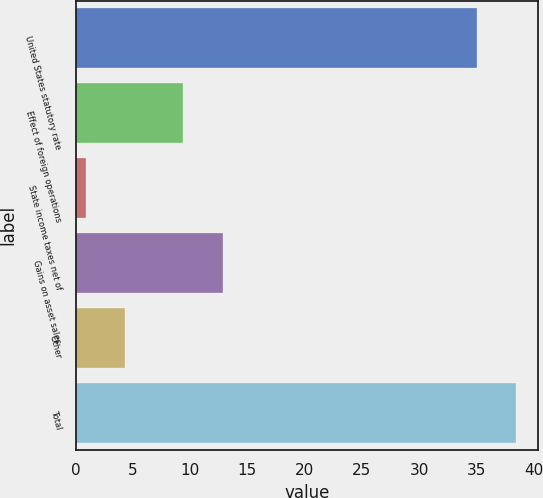Convert chart to OTSL. <chart><loc_0><loc_0><loc_500><loc_500><bar_chart><fcel>United States statutory rate<fcel>Effect of foreign operations<fcel>State income taxes net of<fcel>Gains on asset sales<fcel>Other<fcel>Total<nl><fcel>35<fcel>9.4<fcel>0.9<fcel>12.85<fcel>4.35<fcel>38.45<nl></chart> 